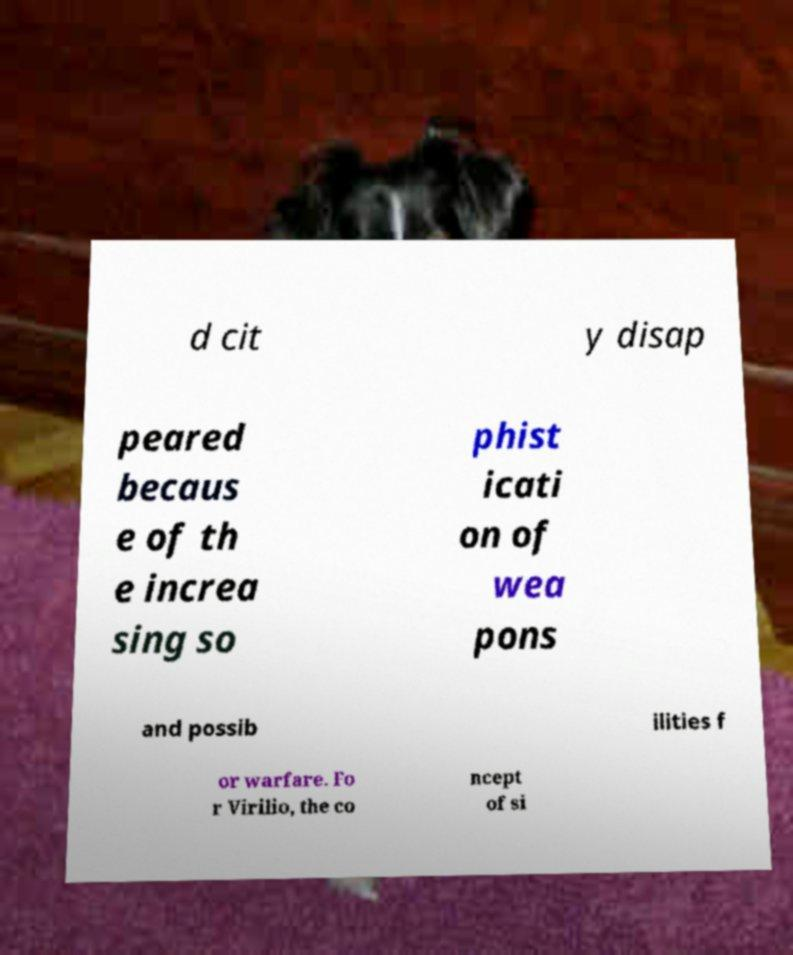Please identify and transcribe the text found in this image. d cit y disap peared becaus e of th e increa sing so phist icati on of wea pons and possib ilities f or warfare. Fo r Virilio, the co ncept of si 